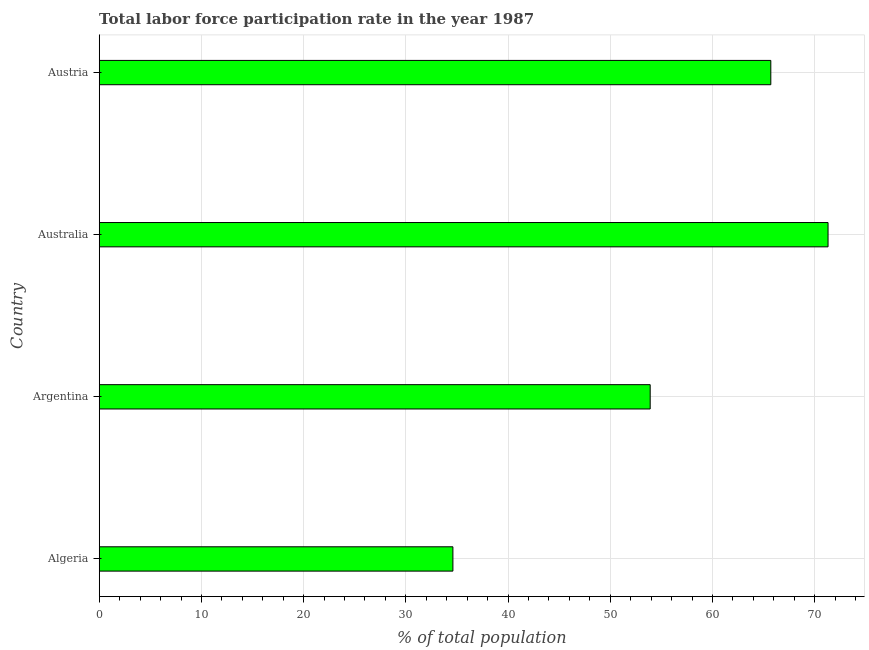Does the graph contain any zero values?
Offer a terse response. No. What is the title of the graph?
Give a very brief answer. Total labor force participation rate in the year 1987. What is the label or title of the X-axis?
Your answer should be very brief. % of total population. What is the label or title of the Y-axis?
Offer a terse response. Country. What is the total labor force participation rate in Australia?
Your answer should be very brief. 71.3. Across all countries, what is the maximum total labor force participation rate?
Offer a very short reply. 71.3. Across all countries, what is the minimum total labor force participation rate?
Give a very brief answer. 34.6. In which country was the total labor force participation rate minimum?
Provide a short and direct response. Algeria. What is the sum of the total labor force participation rate?
Ensure brevity in your answer.  225.5. What is the difference between the total labor force participation rate in Algeria and Australia?
Provide a succinct answer. -36.7. What is the average total labor force participation rate per country?
Make the answer very short. 56.38. What is the median total labor force participation rate?
Provide a succinct answer. 59.8. What is the ratio of the total labor force participation rate in Argentina to that in Australia?
Your answer should be very brief. 0.76. Is the sum of the total labor force participation rate in Argentina and Australia greater than the maximum total labor force participation rate across all countries?
Your answer should be compact. Yes. What is the difference between the highest and the lowest total labor force participation rate?
Keep it short and to the point. 36.7. In how many countries, is the total labor force participation rate greater than the average total labor force participation rate taken over all countries?
Keep it short and to the point. 2. Are all the bars in the graph horizontal?
Your answer should be very brief. Yes. How many countries are there in the graph?
Make the answer very short. 4. What is the % of total population in Algeria?
Provide a succinct answer. 34.6. What is the % of total population in Argentina?
Your answer should be compact. 53.9. What is the % of total population in Australia?
Keep it short and to the point. 71.3. What is the % of total population of Austria?
Provide a succinct answer. 65.7. What is the difference between the % of total population in Algeria and Argentina?
Provide a short and direct response. -19.3. What is the difference between the % of total population in Algeria and Australia?
Offer a very short reply. -36.7. What is the difference between the % of total population in Algeria and Austria?
Ensure brevity in your answer.  -31.1. What is the difference between the % of total population in Argentina and Australia?
Make the answer very short. -17.4. What is the difference between the % of total population in Australia and Austria?
Provide a succinct answer. 5.6. What is the ratio of the % of total population in Algeria to that in Argentina?
Ensure brevity in your answer.  0.64. What is the ratio of the % of total population in Algeria to that in Australia?
Offer a terse response. 0.48. What is the ratio of the % of total population in Algeria to that in Austria?
Your response must be concise. 0.53. What is the ratio of the % of total population in Argentina to that in Australia?
Your answer should be very brief. 0.76. What is the ratio of the % of total population in Argentina to that in Austria?
Your answer should be very brief. 0.82. What is the ratio of the % of total population in Australia to that in Austria?
Your answer should be very brief. 1.08. 